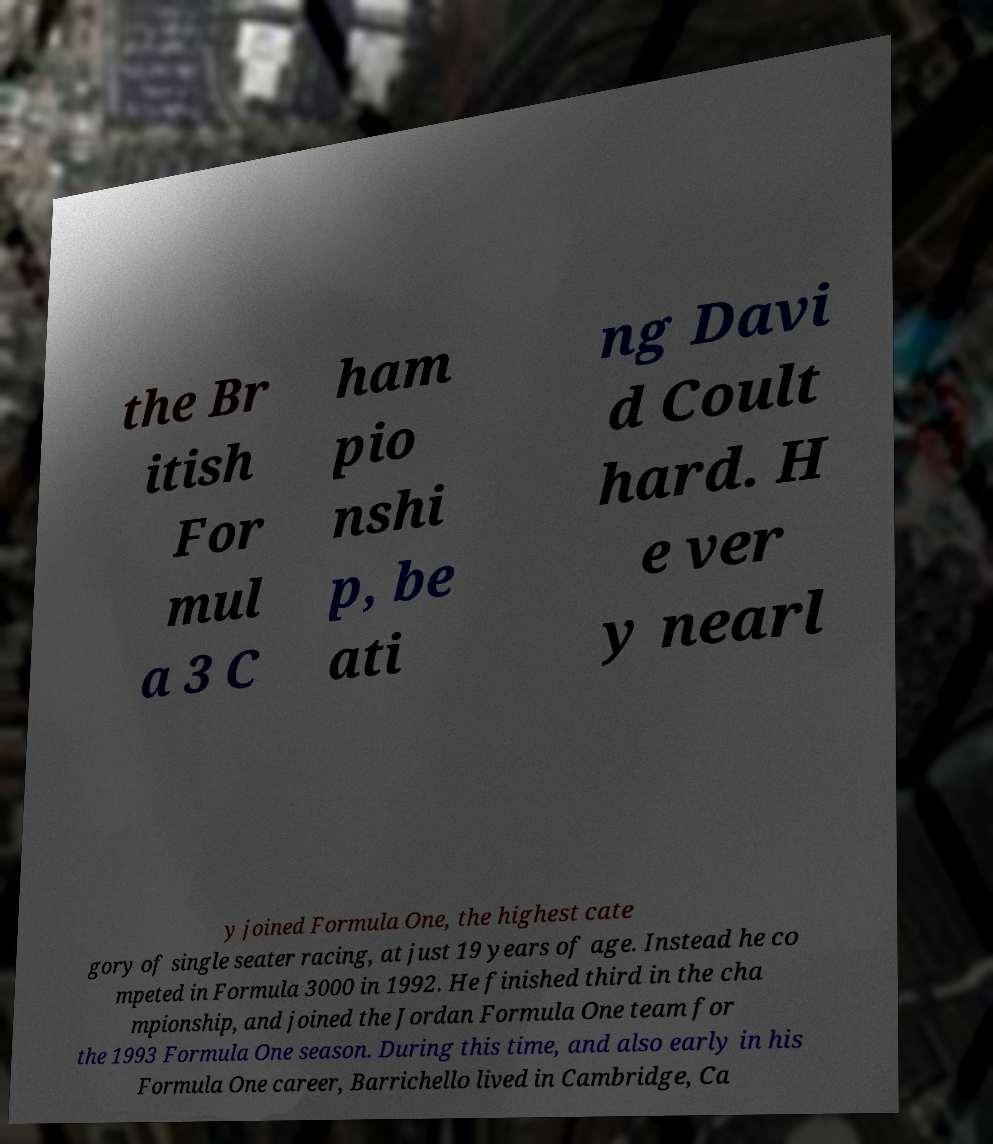I need the written content from this picture converted into text. Can you do that? the Br itish For mul a 3 C ham pio nshi p, be ati ng Davi d Coult hard. H e ver y nearl y joined Formula One, the highest cate gory of single seater racing, at just 19 years of age. Instead he co mpeted in Formula 3000 in 1992. He finished third in the cha mpionship, and joined the Jordan Formula One team for the 1993 Formula One season. During this time, and also early in his Formula One career, Barrichello lived in Cambridge, Ca 